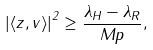<formula> <loc_0><loc_0><loc_500><loc_500>\left | \langle z , v \rangle \right | ^ { 2 } \geq \frac { \lambda _ { H } - \lambda _ { R } } { M p } ,</formula> 